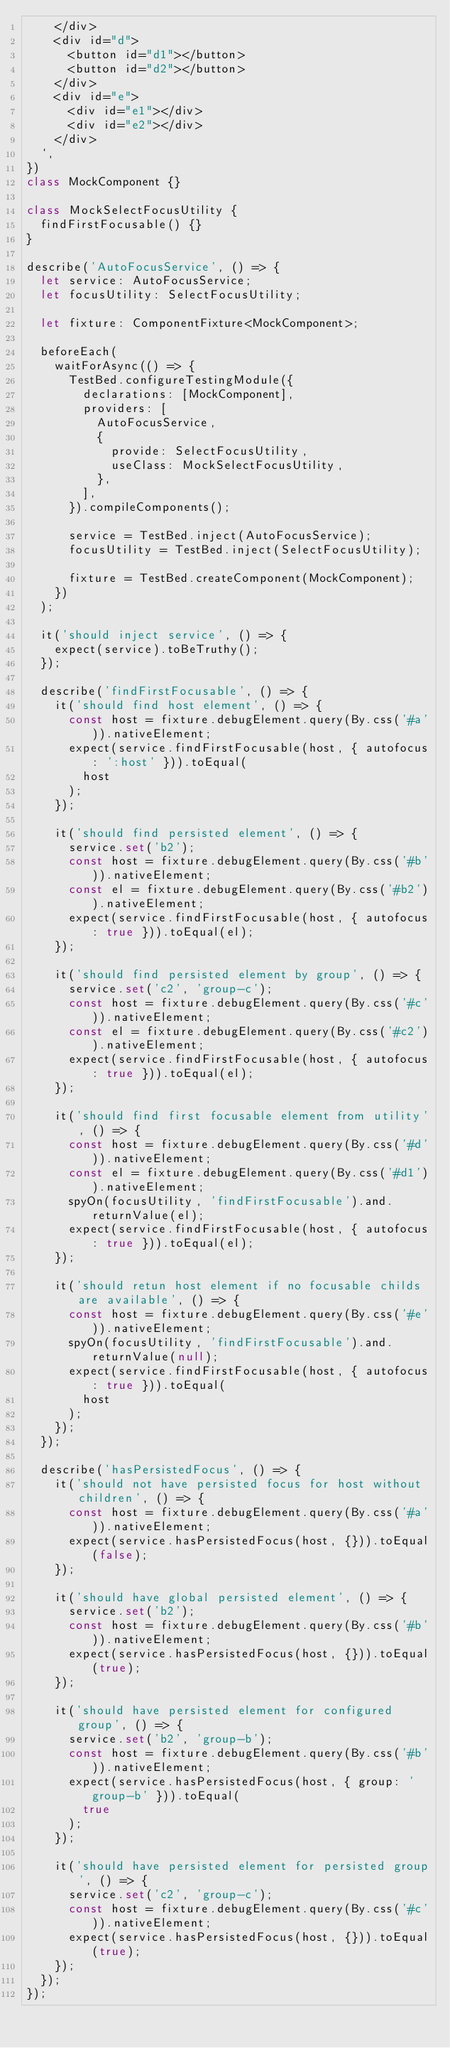<code> <loc_0><loc_0><loc_500><loc_500><_TypeScript_>    </div>
    <div id="d">
      <button id="d1"></button>
      <button id="d2"></button>
    </div>
    <div id="e">
      <div id="e1"></div>
      <div id="e2"></div>
    </div>
  `,
})
class MockComponent {}

class MockSelectFocusUtility {
  findFirstFocusable() {}
}

describe('AutoFocusService', () => {
  let service: AutoFocusService;
  let focusUtility: SelectFocusUtility;

  let fixture: ComponentFixture<MockComponent>;

  beforeEach(
    waitForAsync(() => {
      TestBed.configureTestingModule({
        declarations: [MockComponent],
        providers: [
          AutoFocusService,
          {
            provide: SelectFocusUtility,
            useClass: MockSelectFocusUtility,
          },
        ],
      }).compileComponents();

      service = TestBed.inject(AutoFocusService);
      focusUtility = TestBed.inject(SelectFocusUtility);

      fixture = TestBed.createComponent(MockComponent);
    })
  );

  it('should inject service', () => {
    expect(service).toBeTruthy();
  });

  describe('findFirstFocusable', () => {
    it('should find host element', () => {
      const host = fixture.debugElement.query(By.css('#a')).nativeElement;
      expect(service.findFirstFocusable(host, { autofocus: ':host' })).toEqual(
        host
      );
    });

    it('should find persisted element', () => {
      service.set('b2');
      const host = fixture.debugElement.query(By.css('#b')).nativeElement;
      const el = fixture.debugElement.query(By.css('#b2')).nativeElement;
      expect(service.findFirstFocusable(host, { autofocus: true })).toEqual(el);
    });

    it('should find persisted element by group', () => {
      service.set('c2', 'group-c');
      const host = fixture.debugElement.query(By.css('#c')).nativeElement;
      const el = fixture.debugElement.query(By.css('#c2')).nativeElement;
      expect(service.findFirstFocusable(host, { autofocus: true })).toEqual(el);
    });

    it('should find first focusable element from utility', () => {
      const host = fixture.debugElement.query(By.css('#d')).nativeElement;
      const el = fixture.debugElement.query(By.css('#d1')).nativeElement;
      spyOn(focusUtility, 'findFirstFocusable').and.returnValue(el);
      expect(service.findFirstFocusable(host, { autofocus: true })).toEqual(el);
    });

    it('should retun host element if no focusable childs are available', () => {
      const host = fixture.debugElement.query(By.css('#e')).nativeElement;
      spyOn(focusUtility, 'findFirstFocusable').and.returnValue(null);
      expect(service.findFirstFocusable(host, { autofocus: true })).toEqual(
        host
      );
    });
  });

  describe('hasPersistedFocus', () => {
    it('should not have persisted focus for host without children', () => {
      const host = fixture.debugElement.query(By.css('#a')).nativeElement;
      expect(service.hasPersistedFocus(host, {})).toEqual(false);
    });

    it('should have global persisted element', () => {
      service.set('b2');
      const host = fixture.debugElement.query(By.css('#b')).nativeElement;
      expect(service.hasPersistedFocus(host, {})).toEqual(true);
    });

    it('should have persisted element for configured group', () => {
      service.set('b2', 'group-b');
      const host = fixture.debugElement.query(By.css('#b')).nativeElement;
      expect(service.hasPersistedFocus(host, { group: 'group-b' })).toEqual(
        true
      );
    });

    it('should have persisted element for persisted group', () => {
      service.set('c2', 'group-c');
      const host = fixture.debugElement.query(By.css('#c')).nativeElement;
      expect(service.hasPersistedFocus(host, {})).toEqual(true);
    });
  });
});
</code> 